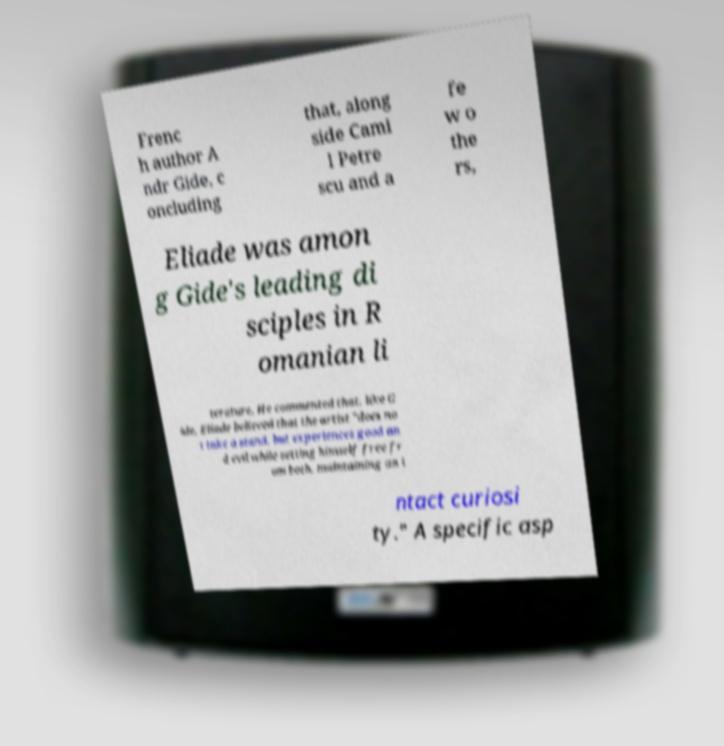Please read and relay the text visible in this image. What does it say? Frenc h author A ndr Gide, c oncluding that, along side Cami l Petre scu and a fe w o the rs, Eliade was amon g Gide's leading di sciples in R omanian li terature. He commented that, like G ide, Eliade believed that the artist "does no t take a stand, but experiences good an d evil while setting himself free fr om both, maintaining an i ntact curiosi ty." A specific asp 